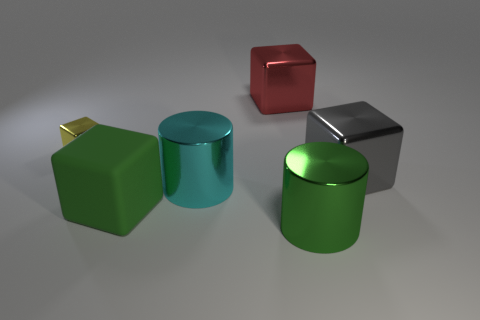Is there any other thing that has the same size as the yellow cube?
Offer a terse response. No. There is a green thing left of the large shiny object behind the small yellow thing; what is its material?
Provide a succinct answer. Rubber. Is there a large cyan object of the same shape as the tiny object?
Provide a short and direct response. No. What number of other objects are the same shape as the large green shiny thing?
Keep it short and to the point. 1. There is a metallic object that is both on the left side of the large red metal object and to the right of the small block; what is its shape?
Your answer should be very brief. Cylinder. There is a block that is to the left of the large matte cube; what size is it?
Give a very brief answer. Small. Is the yellow thing the same size as the cyan metal thing?
Give a very brief answer. No. Are there fewer big green shiny cylinders left of the large green metallic cylinder than big things behind the large gray metallic block?
Keep it short and to the point. Yes. There is a cube that is both behind the matte cube and left of the big red block; how big is it?
Your answer should be very brief. Small. There is a cylinder that is behind the cylinder that is in front of the green block; is there a metallic object that is behind it?
Make the answer very short. Yes. 